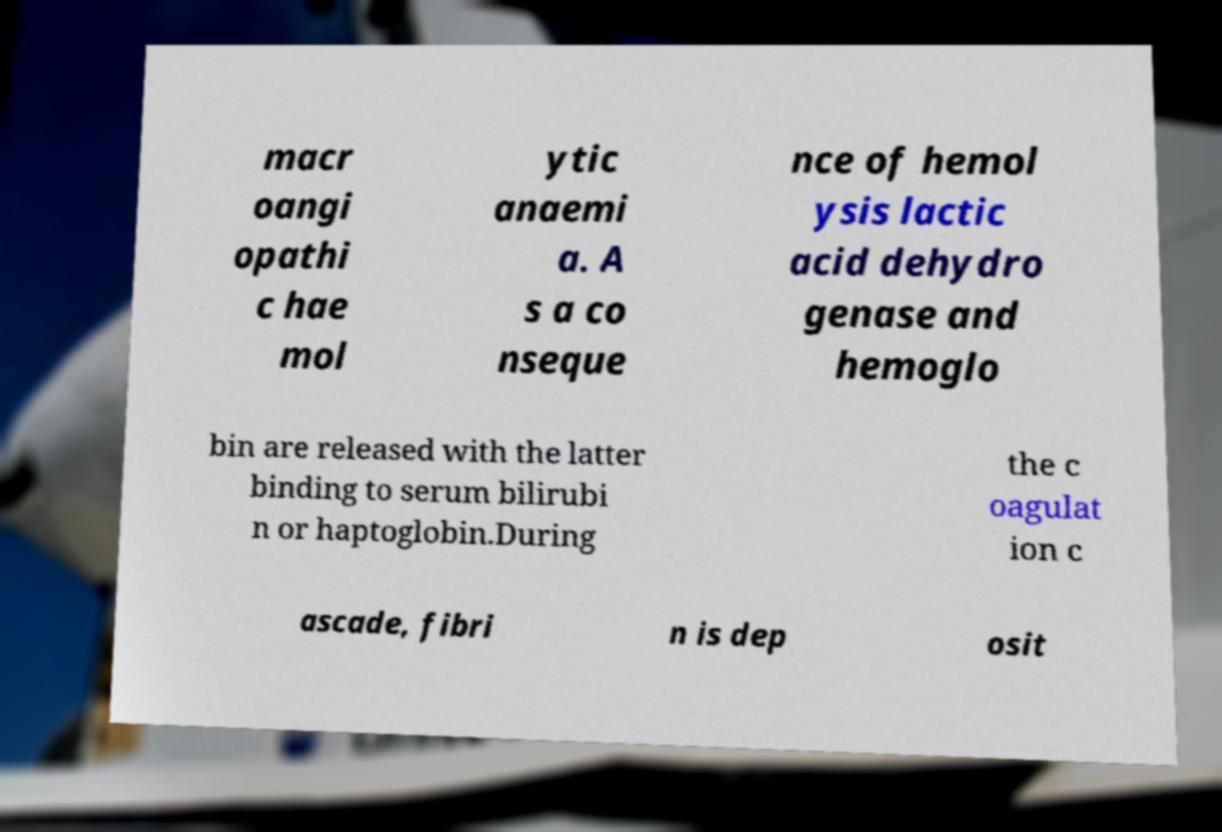Please identify and transcribe the text found in this image. macr oangi opathi c hae mol ytic anaemi a. A s a co nseque nce of hemol ysis lactic acid dehydro genase and hemoglo bin are released with the latter binding to serum bilirubi n or haptoglobin.During the c oagulat ion c ascade, fibri n is dep osit 